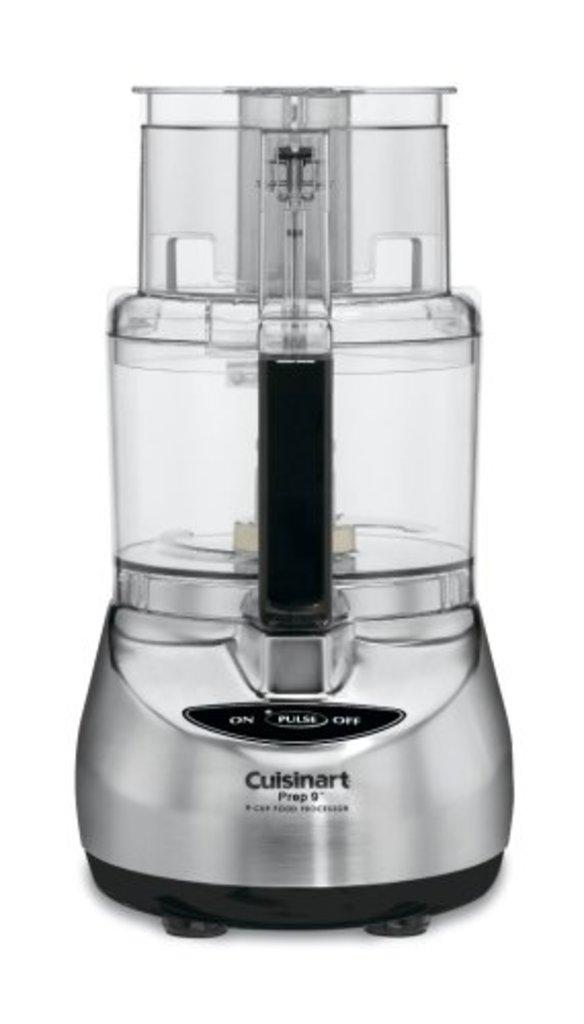<image>
Share a concise interpretation of the image provided. A stock photo for a Cuisinart food processor. 